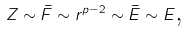Convert formula to latex. <formula><loc_0><loc_0><loc_500><loc_500>Z \sim \bar { F } \sim r ^ { p - 2 } \sim \bar { E } \sim E \text {,}</formula> 